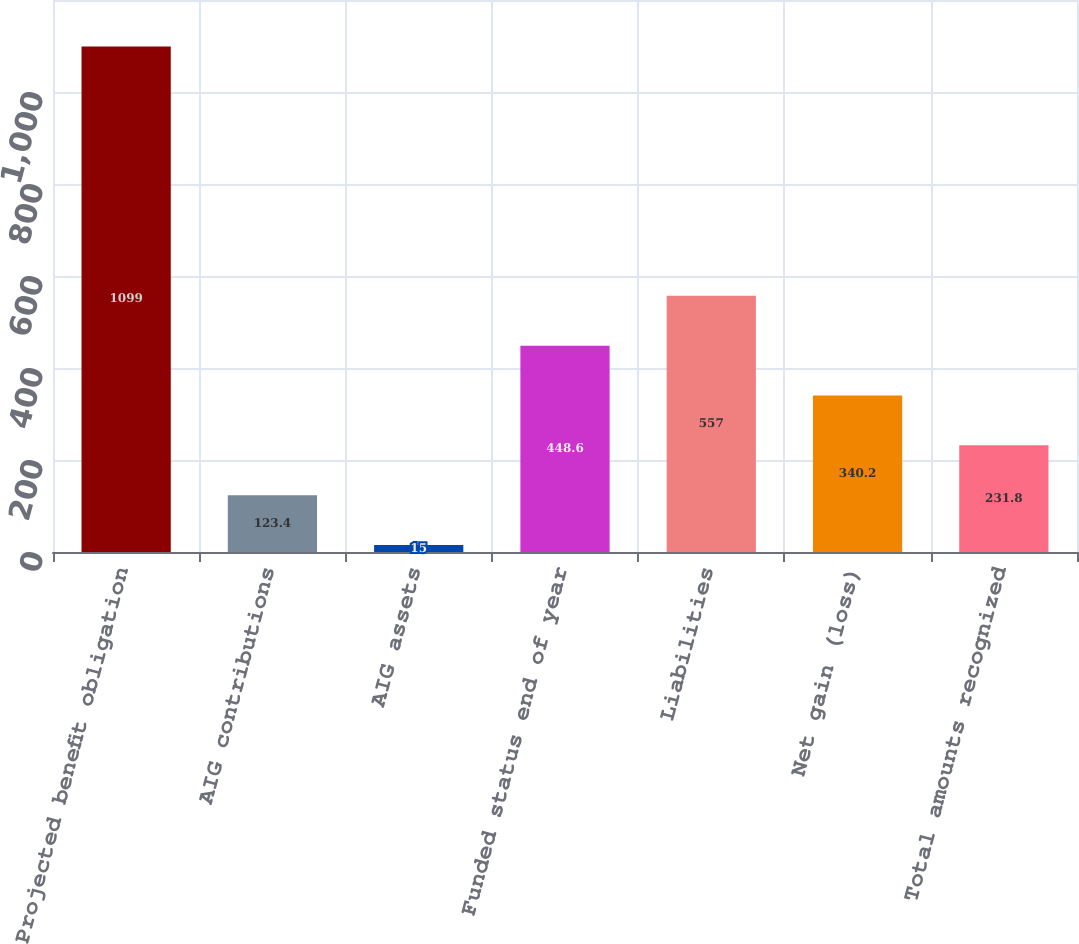Convert chart to OTSL. <chart><loc_0><loc_0><loc_500><loc_500><bar_chart><fcel>Projected benefit obligation<fcel>AIG contributions<fcel>AIG assets<fcel>Funded status end of year<fcel>Liabilities<fcel>Net gain (loss)<fcel>Total amounts recognized<nl><fcel>1099<fcel>123.4<fcel>15<fcel>448.6<fcel>557<fcel>340.2<fcel>231.8<nl></chart> 